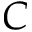<formula> <loc_0><loc_0><loc_500><loc_500>C</formula> 